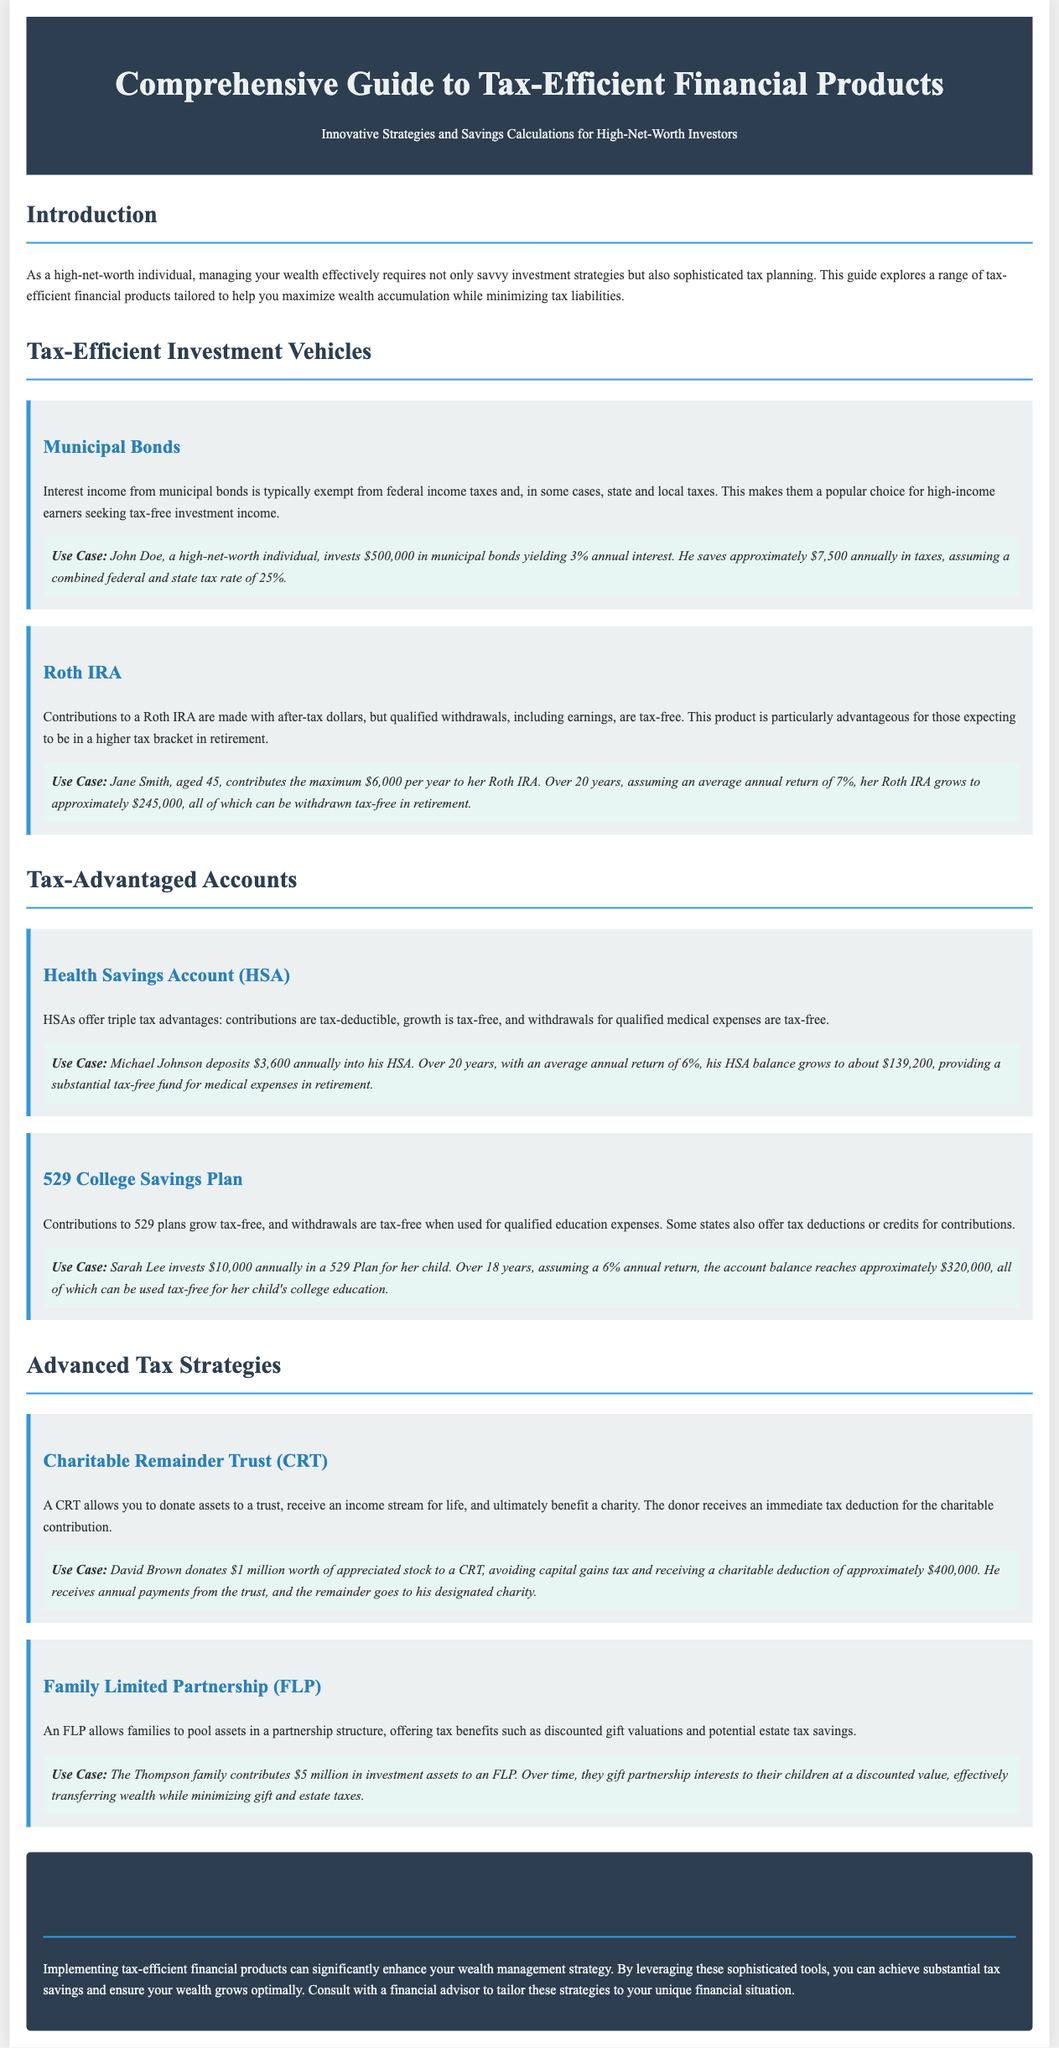What is the title of the document? The title of the document is prominently displayed in the header section, stating the subject matter covered.
Answer: Comprehensive Guide to Tax-Efficient Financial Products What type of individual is this guide tailored for? The introduction specifies the target audience for this guide, detailing their characteristics and financial needs.
Answer: High-net-worth individual What is the annual interest yield of the municipal bonds example? The document provides a specific example with interest rates for various tax-efficient financial products.
Answer: 3% How much does Jane Smith contribute annually to her Roth IRA? This detail is provided in the use case scenario of the Roth IRA section, specifying the contribution amount.
Answer: $6,000 What is the total expected growth of Sarah Lee's 529 Plan over 18 years? The use case scenario for the 529 Plan states the projected account balance at the end of the specified period.
Answer: $320,000 What are the three tax advantages of a Health Savings Account (HSA)? The document lists the benefits of HSAs in a concise manner, outlining its tax advantages.
Answer: Triple tax advantages What amount did David Brown donate to the Charitable Remainder Trust (CRT)? The specific donation amount is included in the use case scenario pertaining to the CRT.
Answer: $1 million What type of tax-saving strategies does this guide conclude with? The conclusion briefly summarizes the financial products discussed, emphasizing their benefits in tax savings.
Answer: Advanced Tax Strategies What is the expected annual return for Michael Johnson's HSA deposit? The use case scenario for the HSA mentions the assumed average annual return over 20 years.
Answer: 6% 